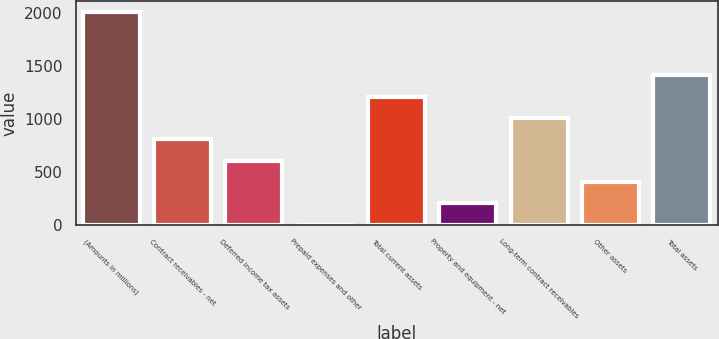Convert chart to OTSL. <chart><loc_0><loc_0><loc_500><loc_500><bar_chart><fcel>(Amounts in millions)<fcel>Contract receivables - net<fcel>Deferred income tax assets<fcel>Prepaid expenses and other<fcel>Total current assets<fcel>Property and equipment - net<fcel>Long-term contract receivables<fcel>Other assets<fcel>Total assets<nl><fcel>2011<fcel>804.94<fcel>603.93<fcel>0.9<fcel>1206.96<fcel>201.91<fcel>1005.95<fcel>402.92<fcel>1407.97<nl></chart> 